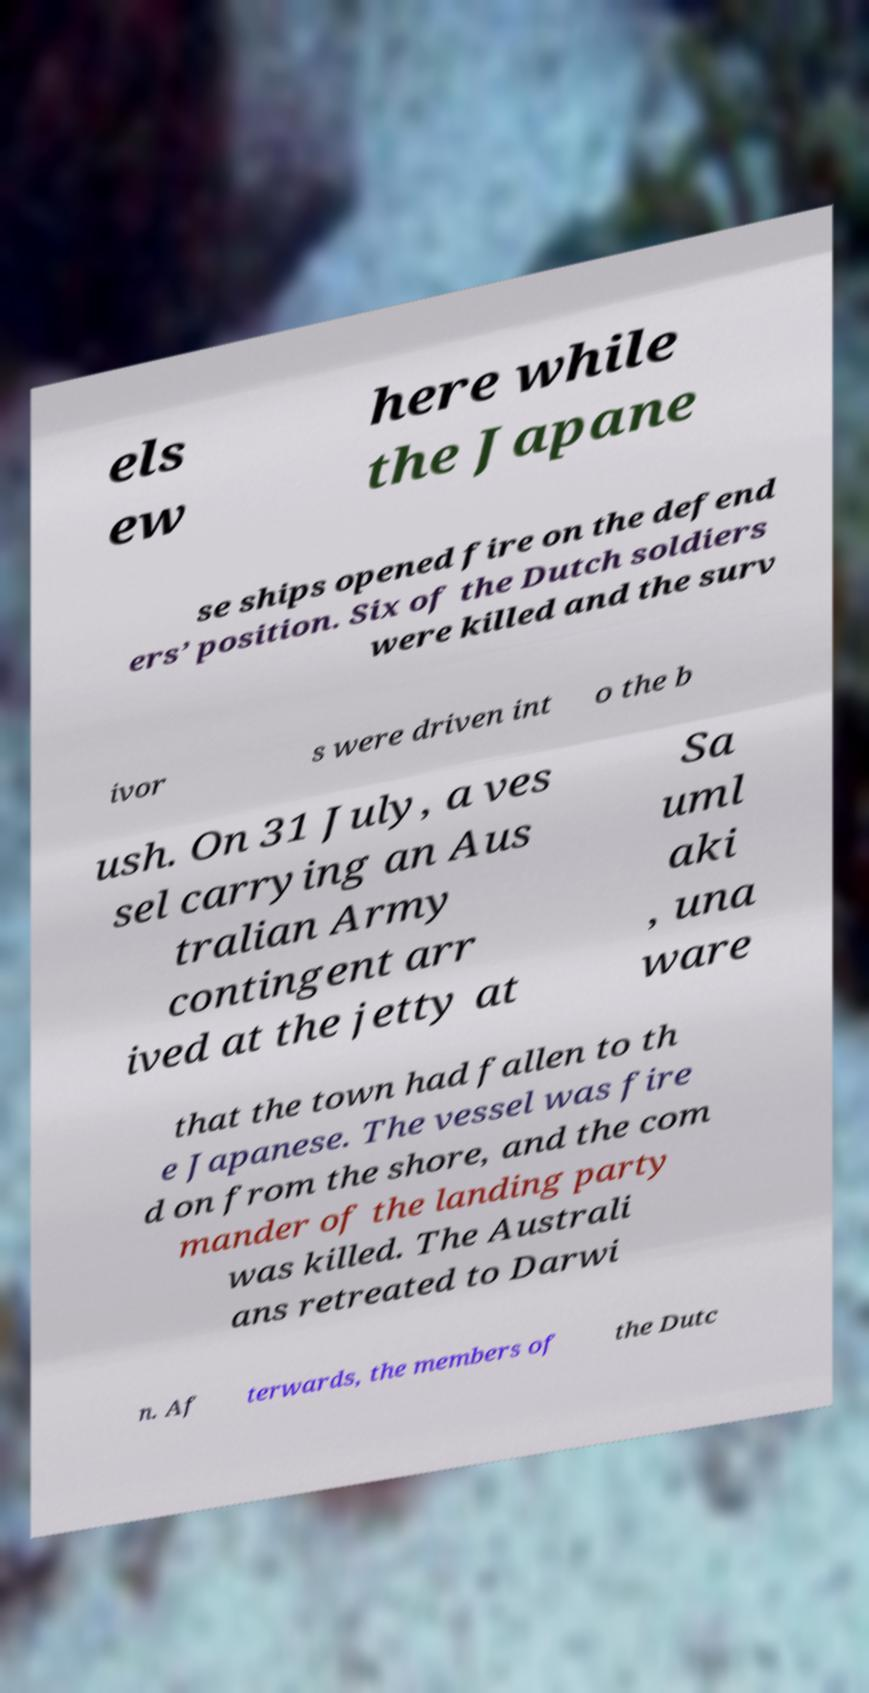For documentation purposes, I need the text within this image transcribed. Could you provide that? els ew here while the Japane se ships opened fire on the defend ers’ position. Six of the Dutch soldiers were killed and the surv ivor s were driven int o the b ush. On 31 July, a ves sel carrying an Aus tralian Army contingent arr ived at the jetty at Sa uml aki , una ware that the town had fallen to th e Japanese. The vessel was fire d on from the shore, and the com mander of the landing party was killed. The Australi ans retreated to Darwi n. Af terwards, the members of the Dutc 